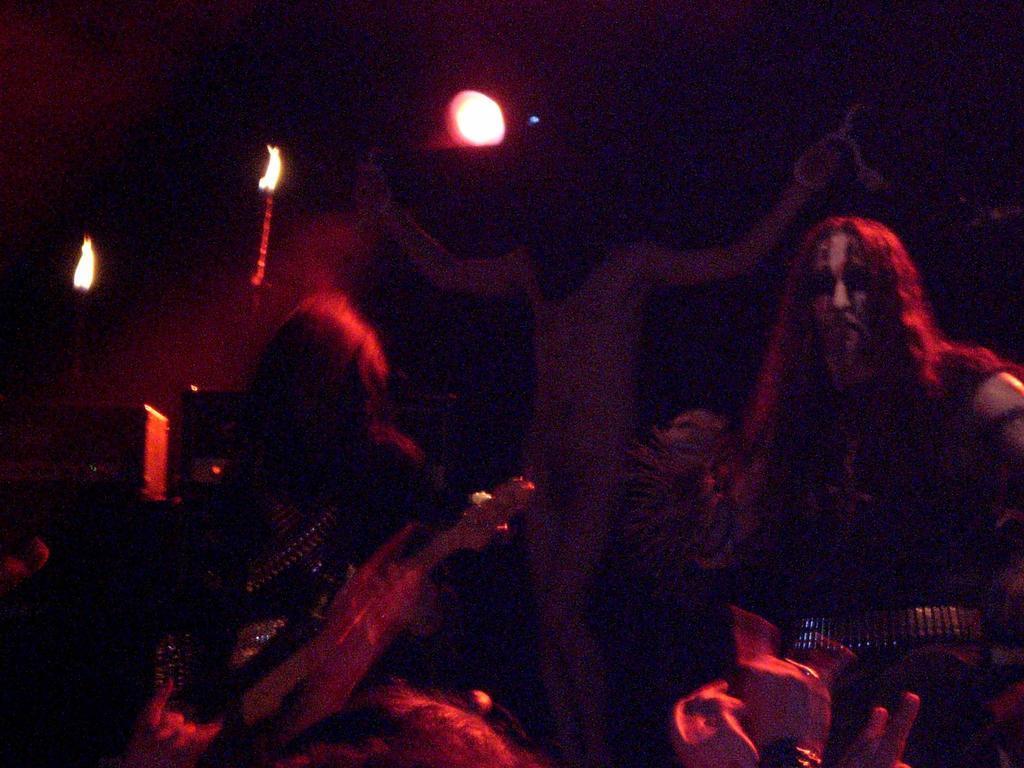How would you summarize this image in a sentence or two? On the right side, there is a person. On the left side, there is a person. In the background, there is a person on the cross and there are lights. And the background is dark in color. 